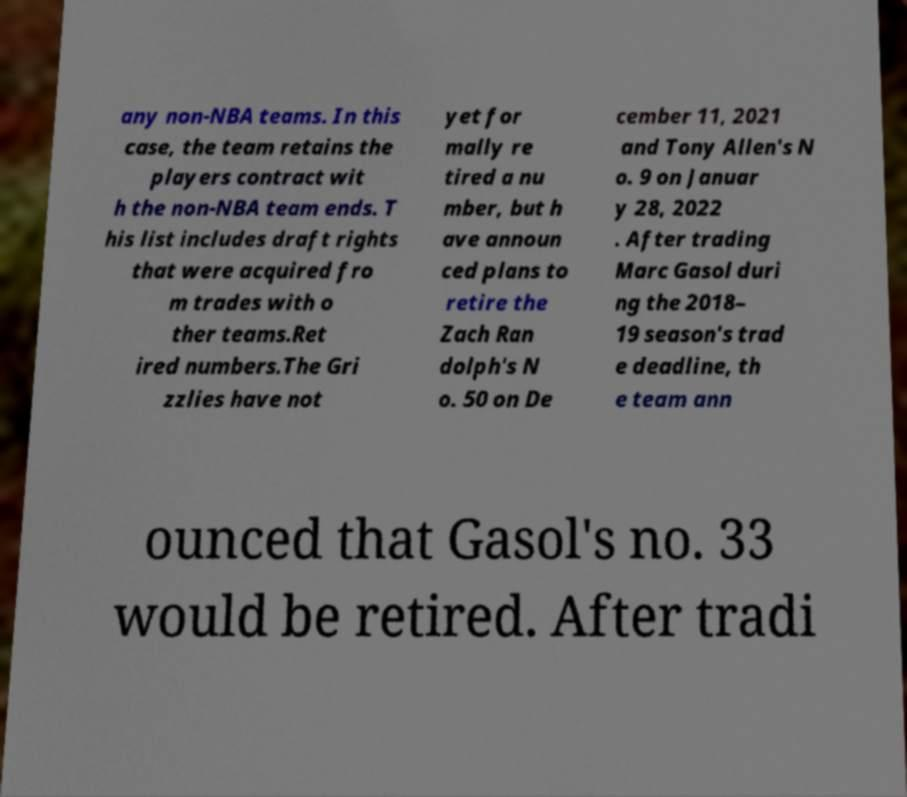Could you assist in decoding the text presented in this image and type it out clearly? any non-NBA teams. In this case, the team retains the players contract wit h the non-NBA team ends. T his list includes draft rights that were acquired fro m trades with o ther teams.Ret ired numbers.The Gri zzlies have not yet for mally re tired a nu mber, but h ave announ ced plans to retire the Zach Ran dolph's N o. 50 on De cember 11, 2021 and Tony Allen's N o. 9 on Januar y 28, 2022 . After trading Marc Gasol duri ng the 2018– 19 season's trad e deadline, th e team ann ounced that Gasol's no. 33 would be retired. After tradi 